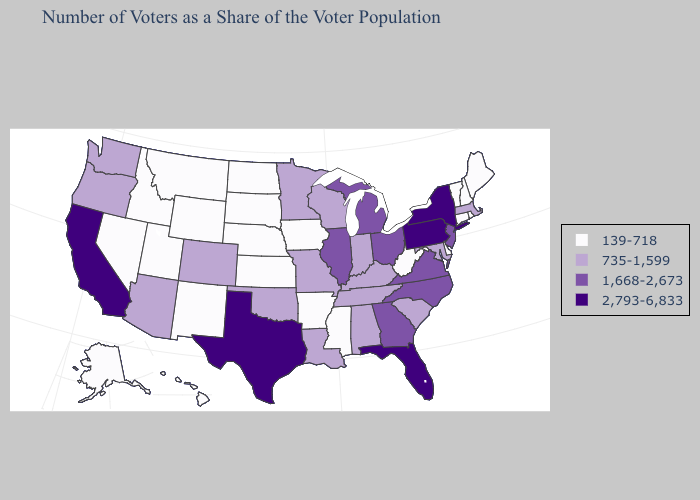What is the value of Maine?
Keep it brief. 139-718. Among the states that border Minnesota , does Wisconsin have the lowest value?
Quick response, please. No. Name the states that have a value in the range 1,668-2,673?
Quick response, please. Georgia, Illinois, Michigan, New Jersey, North Carolina, Ohio, Virginia. What is the highest value in states that border Arizona?
Concise answer only. 2,793-6,833. What is the value of Minnesota?
Quick response, please. 735-1,599. What is the value of Mississippi?
Quick response, please. 139-718. What is the highest value in states that border Massachusetts?
Be succinct. 2,793-6,833. Which states have the highest value in the USA?
Short answer required. California, Florida, New York, Pennsylvania, Texas. Among the states that border Colorado , which have the lowest value?
Concise answer only. Kansas, Nebraska, New Mexico, Utah, Wyoming. What is the lowest value in the USA?
Be succinct. 139-718. Which states hav the highest value in the South?
Concise answer only. Florida, Texas. What is the highest value in the West ?
Write a very short answer. 2,793-6,833. Name the states that have a value in the range 1,668-2,673?
Concise answer only. Georgia, Illinois, Michigan, New Jersey, North Carolina, Ohio, Virginia. Name the states that have a value in the range 1,668-2,673?
Give a very brief answer. Georgia, Illinois, Michigan, New Jersey, North Carolina, Ohio, Virginia. Name the states that have a value in the range 735-1,599?
Give a very brief answer. Alabama, Arizona, Colorado, Indiana, Kentucky, Louisiana, Maryland, Massachusetts, Minnesota, Missouri, Oklahoma, Oregon, South Carolina, Tennessee, Washington, Wisconsin. 